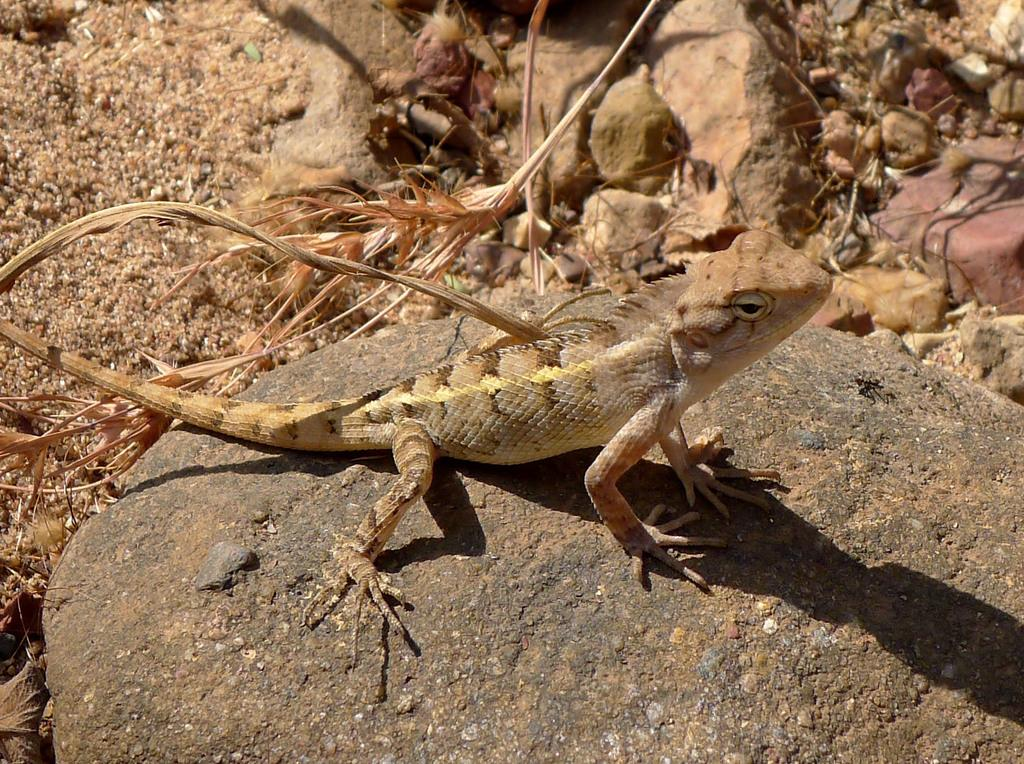What type of animal is in the image? There is a reptile in the image. What colors can be seen on the reptile? The reptile has cream and brown colors. Where is the reptile located in the image? The reptile is on a stone. What can be seen in the background of the image? There are stones and dried leaves visible in the background of the image. What type of crime is being committed by the wool in the image? There is no wool present in the image, and therefore no crime can be committed by it. 